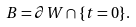Convert formula to latex. <formula><loc_0><loc_0><loc_500><loc_500>B = \partial W \cap \{ t = 0 \} .</formula> 